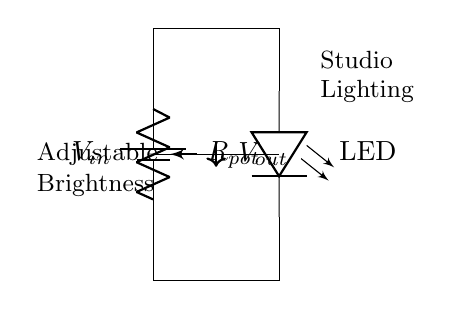What is the input voltage in this circuit? The input voltage is labeled as V in the circuit diagram, which represents the voltage supplied to the circuit.
Answer: V in What component is used to adjust the brightness of the LED? The brightness of the LED is controlled by the potentiometer, indicated as R pot in the circuit. The resistance varies and thus changes the voltage at the LED, affecting its brightness.
Answer: R pot How many main components are visible in the circuit? The circuit consists of three main components: a battery, a potentiometer, and an LED. This is evident from the labeled elements in the diagram.
Answer: Three What does V out represent in the circuit? V out represents the output voltage across the LED, which is determined by the setting of the potentiometer and is responsible for the brightness level of the LED.
Answer: Output voltage What is the relationship between R pot and the brightness of the LED? As R pot changes its resistance setting, the voltage drop across it changes. This alters the voltage at V out, which directly influences the brightness of the LED—higher resistance typically results in lower brightness.
Answer: Resistance affects brightness Which part of the circuit is responsible for the adjustable feature? The adjustable feature is due to the potentiometer, as it allows variations in resistance that control the output voltage; thereby, it adjusts the brightness of the LED.
Answer: Potentiometer 